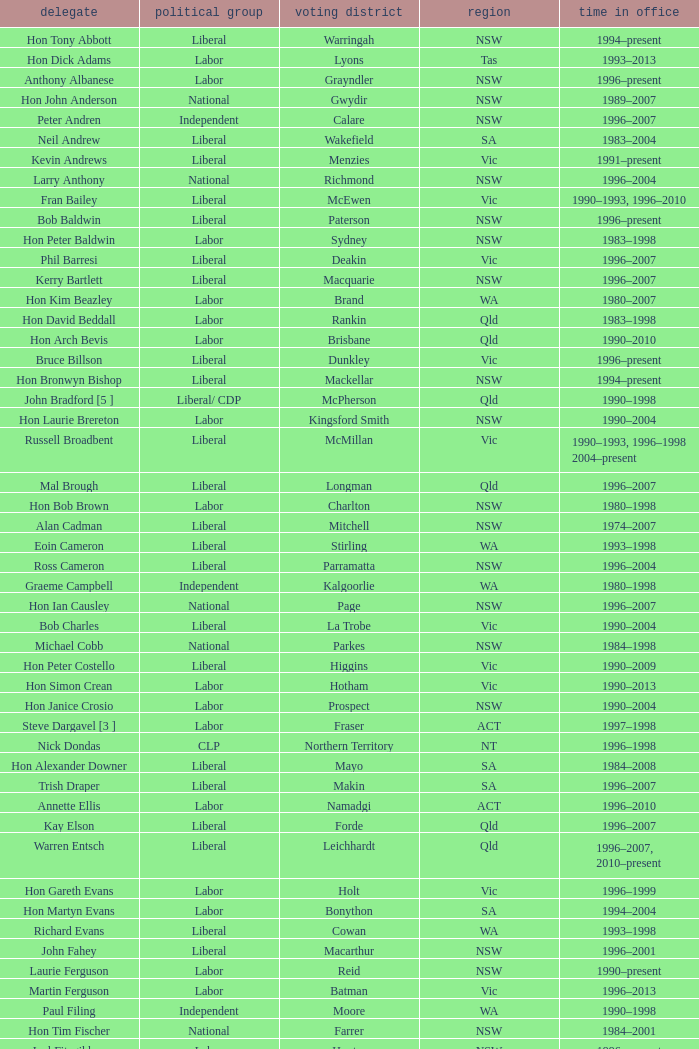In what state was the electorate fowler? NSW. 